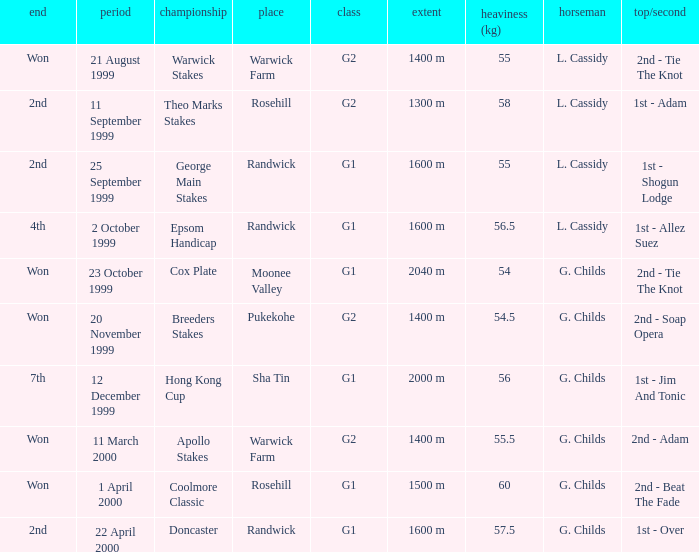List the weight for 56.5 kilograms. Epsom Handicap. 